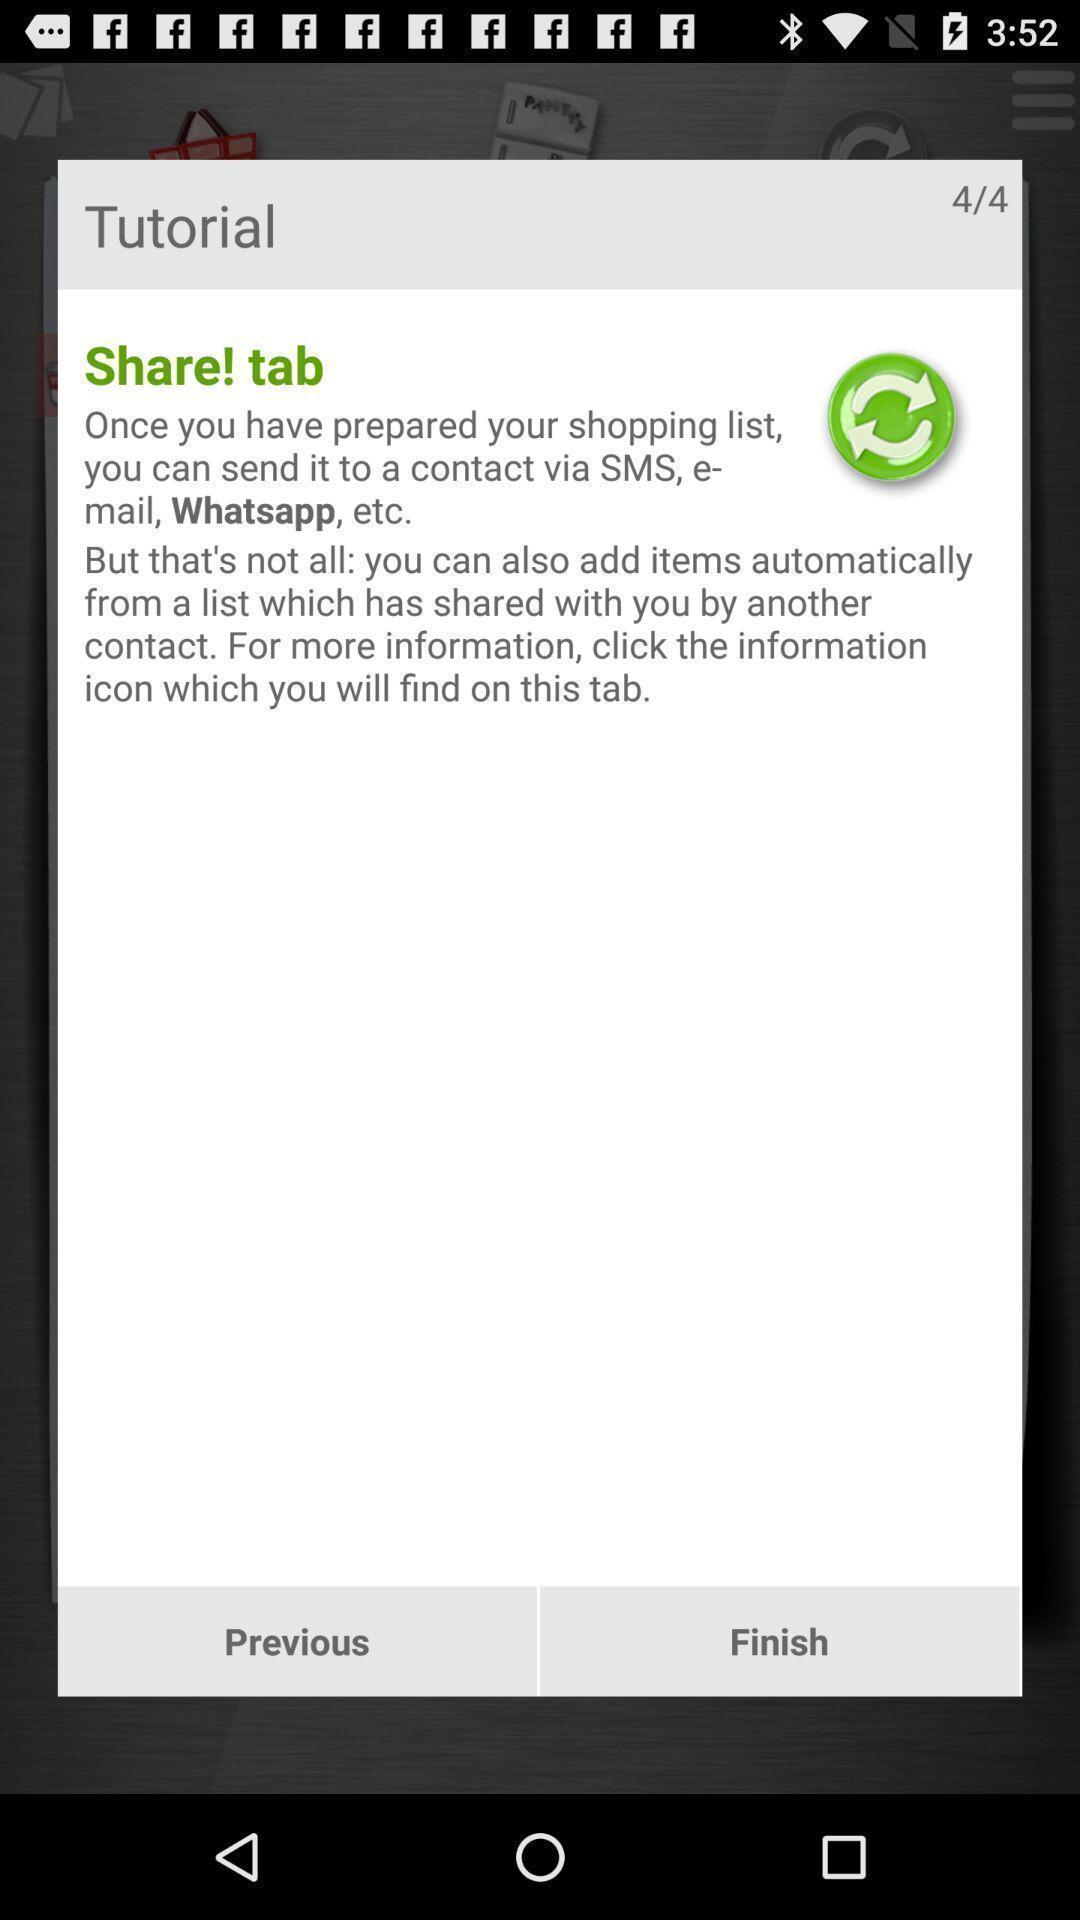Provide a detailed account of this screenshot. Pop-up showing instructions for setting up an app. 